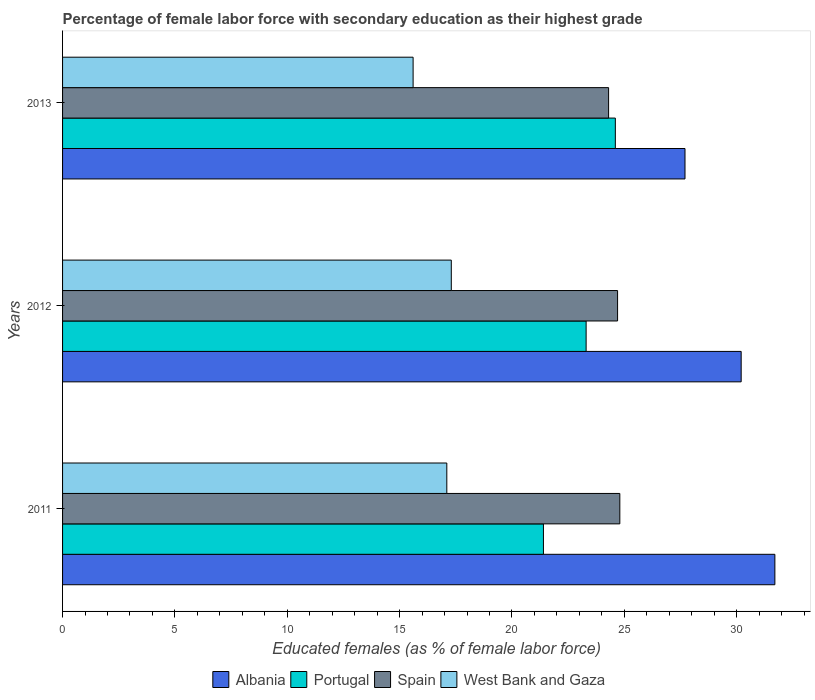How many groups of bars are there?
Provide a short and direct response. 3. Are the number of bars on each tick of the Y-axis equal?
Your answer should be very brief. Yes. How many bars are there on the 2nd tick from the top?
Your response must be concise. 4. What is the percentage of female labor force with secondary education in Spain in 2011?
Your answer should be very brief. 24.8. Across all years, what is the maximum percentage of female labor force with secondary education in West Bank and Gaza?
Give a very brief answer. 17.3. Across all years, what is the minimum percentage of female labor force with secondary education in Albania?
Make the answer very short. 27.7. In which year was the percentage of female labor force with secondary education in West Bank and Gaza maximum?
Provide a short and direct response. 2012. What is the total percentage of female labor force with secondary education in West Bank and Gaza in the graph?
Keep it short and to the point. 50. What is the difference between the percentage of female labor force with secondary education in West Bank and Gaza in 2012 and that in 2013?
Provide a short and direct response. 1.7. What is the difference between the percentage of female labor force with secondary education in Spain in 2011 and the percentage of female labor force with secondary education in Portugal in 2012?
Your answer should be very brief. 1.5. What is the average percentage of female labor force with secondary education in Albania per year?
Offer a very short reply. 29.87. In the year 2012, what is the difference between the percentage of female labor force with secondary education in Albania and percentage of female labor force with secondary education in West Bank and Gaza?
Offer a terse response. 12.9. What is the ratio of the percentage of female labor force with secondary education in Portugal in 2011 to that in 2013?
Offer a very short reply. 0.87. Is the percentage of female labor force with secondary education in Portugal in 2012 less than that in 2013?
Your response must be concise. Yes. Is the difference between the percentage of female labor force with secondary education in Albania in 2012 and 2013 greater than the difference between the percentage of female labor force with secondary education in West Bank and Gaza in 2012 and 2013?
Ensure brevity in your answer.  Yes. What is the difference between the highest and the second highest percentage of female labor force with secondary education in Albania?
Your response must be concise. 1.5. What is the difference between the highest and the lowest percentage of female labor force with secondary education in West Bank and Gaza?
Your answer should be compact. 1.7. What does the 4th bar from the top in 2012 represents?
Your response must be concise. Albania. What does the 4th bar from the bottom in 2011 represents?
Offer a terse response. West Bank and Gaza. Are all the bars in the graph horizontal?
Provide a succinct answer. Yes. How many years are there in the graph?
Give a very brief answer. 3. What is the difference between two consecutive major ticks on the X-axis?
Ensure brevity in your answer.  5. Does the graph contain any zero values?
Offer a terse response. No. Does the graph contain grids?
Make the answer very short. No. What is the title of the graph?
Offer a very short reply. Percentage of female labor force with secondary education as their highest grade. Does "Tunisia" appear as one of the legend labels in the graph?
Make the answer very short. No. What is the label or title of the X-axis?
Give a very brief answer. Educated females (as % of female labor force). What is the Educated females (as % of female labor force) of Albania in 2011?
Ensure brevity in your answer.  31.7. What is the Educated females (as % of female labor force) of Portugal in 2011?
Keep it short and to the point. 21.4. What is the Educated females (as % of female labor force) in Spain in 2011?
Your response must be concise. 24.8. What is the Educated females (as % of female labor force) in West Bank and Gaza in 2011?
Make the answer very short. 17.1. What is the Educated females (as % of female labor force) of Albania in 2012?
Offer a very short reply. 30.2. What is the Educated females (as % of female labor force) in Portugal in 2012?
Give a very brief answer. 23.3. What is the Educated females (as % of female labor force) of Spain in 2012?
Keep it short and to the point. 24.7. What is the Educated females (as % of female labor force) in West Bank and Gaza in 2012?
Provide a succinct answer. 17.3. What is the Educated females (as % of female labor force) of Albania in 2013?
Ensure brevity in your answer.  27.7. What is the Educated females (as % of female labor force) in Portugal in 2013?
Make the answer very short. 24.6. What is the Educated females (as % of female labor force) in Spain in 2013?
Ensure brevity in your answer.  24.3. What is the Educated females (as % of female labor force) of West Bank and Gaza in 2013?
Your response must be concise. 15.6. Across all years, what is the maximum Educated females (as % of female labor force) in Albania?
Your response must be concise. 31.7. Across all years, what is the maximum Educated females (as % of female labor force) of Portugal?
Your response must be concise. 24.6. Across all years, what is the maximum Educated females (as % of female labor force) in Spain?
Offer a very short reply. 24.8. Across all years, what is the maximum Educated females (as % of female labor force) of West Bank and Gaza?
Make the answer very short. 17.3. Across all years, what is the minimum Educated females (as % of female labor force) of Albania?
Provide a succinct answer. 27.7. Across all years, what is the minimum Educated females (as % of female labor force) of Portugal?
Offer a terse response. 21.4. Across all years, what is the minimum Educated females (as % of female labor force) in Spain?
Offer a terse response. 24.3. Across all years, what is the minimum Educated females (as % of female labor force) in West Bank and Gaza?
Offer a terse response. 15.6. What is the total Educated females (as % of female labor force) in Albania in the graph?
Give a very brief answer. 89.6. What is the total Educated females (as % of female labor force) in Portugal in the graph?
Provide a succinct answer. 69.3. What is the total Educated females (as % of female labor force) in Spain in the graph?
Give a very brief answer. 73.8. What is the total Educated females (as % of female labor force) of West Bank and Gaza in the graph?
Provide a short and direct response. 50. What is the difference between the Educated females (as % of female labor force) of Albania in 2011 and that in 2012?
Provide a succinct answer. 1.5. What is the difference between the Educated females (as % of female labor force) in Portugal in 2011 and that in 2012?
Give a very brief answer. -1.9. What is the difference between the Educated females (as % of female labor force) in Spain in 2011 and that in 2012?
Provide a succinct answer. 0.1. What is the difference between the Educated females (as % of female labor force) in West Bank and Gaza in 2011 and that in 2012?
Offer a terse response. -0.2. What is the difference between the Educated females (as % of female labor force) in Albania in 2011 and that in 2013?
Ensure brevity in your answer.  4. What is the difference between the Educated females (as % of female labor force) in Portugal in 2011 and that in 2013?
Your answer should be very brief. -3.2. What is the difference between the Educated females (as % of female labor force) of West Bank and Gaza in 2011 and that in 2013?
Provide a short and direct response. 1.5. What is the difference between the Educated females (as % of female labor force) of Spain in 2012 and that in 2013?
Your response must be concise. 0.4. What is the difference between the Educated females (as % of female labor force) of West Bank and Gaza in 2012 and that in 2013?
Provide a short and direct response. 1.7. What is the difference between the Educated females (as % of female labor force) of Albania in 2011 and the Educated females (as % of female labor force) of Spain in 2012?
Your answer should be compact. 7. What is the difference between the Educated females (as % of female labor force) in Albania in 2011 and the Educated females (as % of female labor force) in West Bank and Gaza in 2012?
Keep it short and to the point. 14.4. What is the difference between the Educated females (as % of female labor force) of Portugal in 2011 and the Educated females (as % of female labor force) of Spain in 2012?
Provide a short and direct response. -3.3. What is the difference between the Educated females (as % of female labor force) of Spain in 2011 and the Educated females (as % of female labor force) of West Bank and Gaza in 2012?
Make the answer very short. 7.5. What is the difference between the Educated females (as % of female labor force) of Albania in 2011 and the Educated females (as % of female labor force) of Portugal in 2013?
Your answer should be compact. 7.1. What is the difference between the Educated females (as % of female labor force) in Portugal in 2011 and the Educated females (as % of female labor force) in West Bank and Gaza in 2013?
Your response must be concise. 5.8. What is the difference between the Educated females (as % of female labor force) of Spain in 2011 and the Educated females (as % of female labor force) of West Bank and Gaza in 2013?
Your answer should be compact. 9.2. What is the difference between the Educated females (as % of female labor force) of Albania in 2012 and the Educated females (as % of female labor force) of Portugal in 2013?
Ensure brevity in your answer.  5.6. What is the difference between the Educated females (as % of female labor force) in Albania in 2012 and the Educated females (as % of female labor force) in Spain in 2013?
Provide a succinct answer. 5.9. What is the difference between the Educated females (as % of female labor force) of Albania in 2012 and the Educated females (as % of female labor force) of West Bank and Gaza in 2013?
Your answer should be very brief. 14.6. What is the difference between the Educated females (as % of female labor force) of Portugal in 2012 and the Educated females (as % of female labor force) of Spain in 2013?
Your response must be concise. -1. What is the difference between the Educated females (as % of female labor force) in Portugal in 2012 and the Educated females (as % of female labor force) in West Bank and Gaza in 2013?
Your answer should be compact. 7.7. What is the difference between the Educated females (as % of female labor force) of Spain in 2012 and the Educated females (as % of female labor force) of West Bank and Gaza in 2013?
Offer a terse response. 9.1. What is the average Educated females (as % of female labor force) of Albania per year?
Your response must be concise. 29.87. What is the average Educated females (as % of female labor force) of Portugal per year?
Provide a succinct answer. 23.1. What is the average Educated females (as % of female labor force) of Spain per year?
Ensure brevity in your answer.  24.6. What is the average Educated females (as % of female labor force) of West Bank and Gaza per year?
Make the answer very short. 16.67. In the year 2011, what is the difference between the Educated females (as % of female labor force) in Albania and Educated females (as % of female labor force) in Spain?
Offer a very short reply. 6.9. In the year 2012, what is the difference between the Educated females (as % of female labor force) of Albania and Educated females (as % of female labor force) of Spain?
Your answer should be very brief. 5.5. In the year 2012, what is the difference between the Educated females (as % of female labor force) in Albania and Educated females (as % of female labor force) in West Bank and Gaza?
Your answer should be very brief. 12.9. In the year 2012, what is the difference between the Educated females (as % of female labor force) in Portugal and Educated females (as % of female labor force) in Spain?
Provide a succinct answer. -1.4. In the year 2012, what is the difference between the Educated females (as % of female labor force) of Portugal and Educated females (as % of female labor force) of West Bank and Gaza?
Your answer should be very brief. 6. In the year 2013, what is the difference between the Educated females (as % of female labor force) in Albania and Educated females (as % of female labor force) in Spain?
Offer a very short reply. 3.4. In the year 2013, what is the difference between the Educated females (as % of female labor force) in Albania and Educated females (as % of female labor force) in West Bank and Gaza?
Provide a succinct answer. 12.1. In the year 2013, what is the difference between the Educated females (as % of female labor force) of Portugal and Educated females (as % of female labor force) of Spain?
Give a very brief answer. 0.3. In the year 2013, what is the difference between the Educated females (as % of female labor force) in Spain and Educated females (as % of female labor force) in West Bank and Gaza?
Offer a very short reply. 8.7. What is the ratio of the Educated females (as % of female labor force) of Albania in 2011 to that in 2012?
Offer a terse response. 1.05. What is the ratio of the Educated females (as % of female labor force) of Portugal in 2011 to that in 2012?
Your answer should be compact. 0.92. What is the ratio of the Educated females (as % of female labor force) of West Bank and Gaza in 2011 to that in 2012?
Your answer should be very brief. 0.99. What is the ratio of the Educated females (as % of female labor force) of Albania in 2011 to that in 2013?
Your answer should be very brief. 1.14. What is the ratio of the Educated females (as % of female labor force) of Portugal in 2011 to that in 2013?
Make the answer very short. 0.87. What is the ratio of the Educated females (as % of female labor force) of Spain in 2011 to that in 2013?
Your answer should be compact. 1.02. What is the ratio of the Educated females (as % of female labor force) in West Bank and Gaza in 2011 to that in 2013?
Offer a terse response. 1.1. What is the ratio of the Educated females (as % of female labor force) in Albania in 2012 to that in 2013?
Offer a terse response. 1.09. What is the ratio of the Educated females (as % of female labor force) in Portugal in 2012 to that in 2013?
Ensure brevity in your answer.  0.95. What is the ratio of the Educated females (as % of female labor force) of Spain in 2012 to that in 2013?
Give a very brief answer. 1.02. What is the ratio of the Educated females (as % of female labor force) of West Bank and Gaza in 2012 to that in 2013?
Offer a very short reply. 1.11. What is the difference between the highest and the lowest Educated females (as % of female labor force) of Albania?
Your answer should be compact. 4. What is the difference between the highest and the lowest Educated females (as % of female labor force) in Portugal?
Ensure brevity in your answer.  3.2. What is the difference between the highest and the lowest Educated females (as % of female labor force) in Spain?
Offer a very short reply. 0.5. 